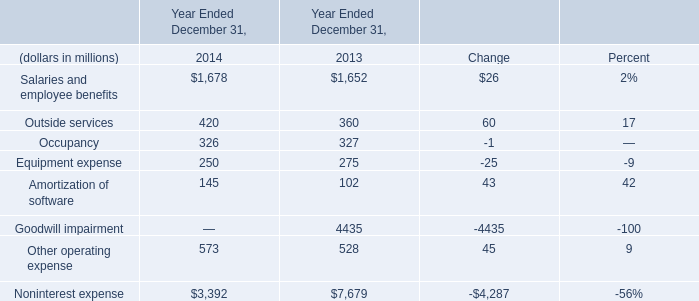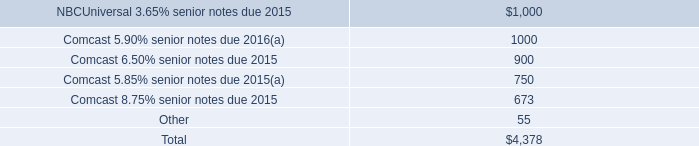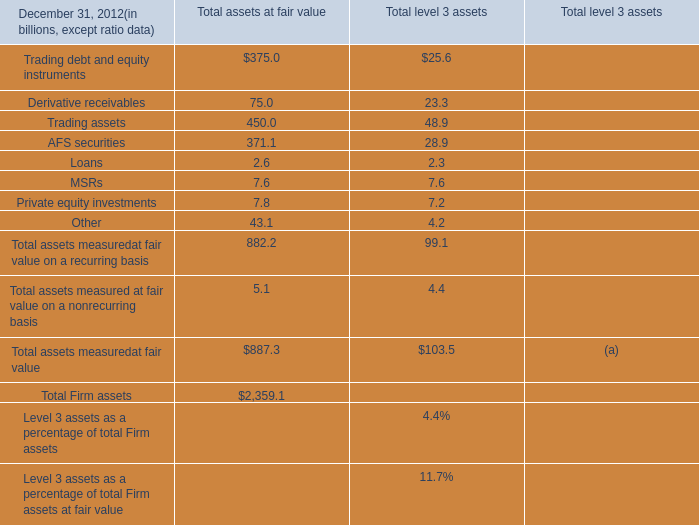What is the highest total amount of Other operating expense? (in dollars in millions) 
Answer: 573. 